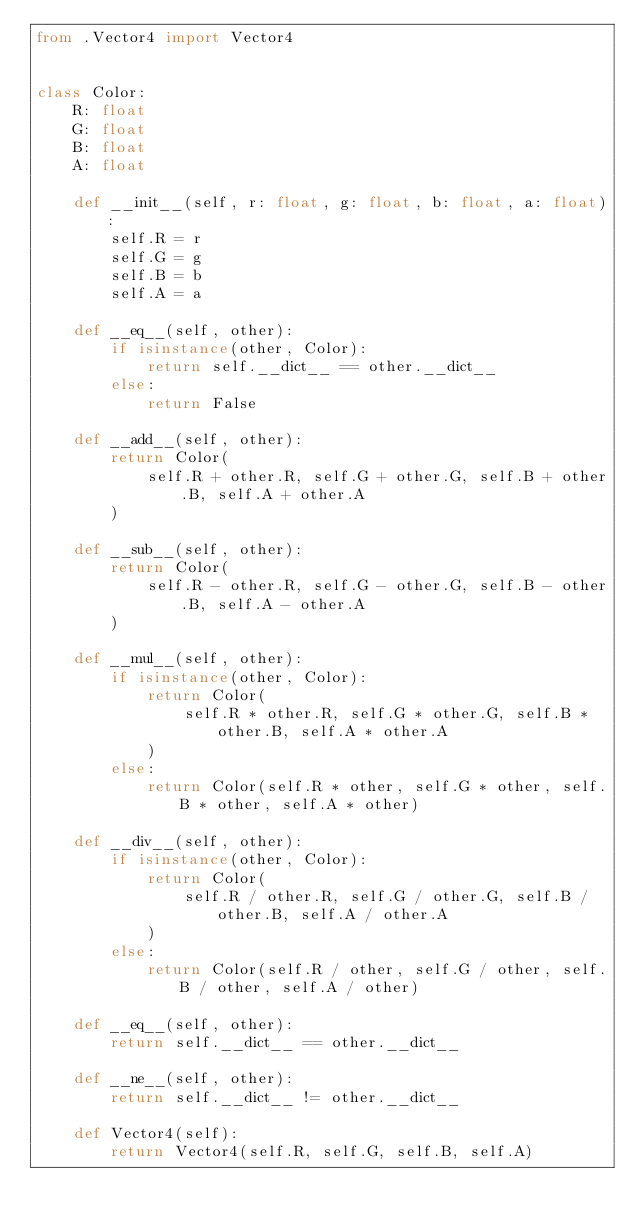Convert code to text. <code><loc_0><loc_0><loc_500><loc_500><_Python_>from .Vector4 import Vector4


class Color:
    R: float
    G: float
    B: float
    A: float

    def __init__(self, r: float, g: float, b: float, a: float):
        self.R = r
        self.G = g
        self.B = b
        self.A = a

    def __eq__(self, other):
        if isinstance(other, Color):
            return self.__dict__ == other.__dict__
        else:
            return False

    def __add__(self, other):
        return Color(
            self.R + other.R, self.G + other.G, self.B + other.B, self.A + other.A
        )

    def __sub__(self, other):
        return Color(
            self.R - other.R, self.G - other.G, self.B - other.B, self.A - other.A
        )

    def __mul__(self, other):
        if isinstance(other, Color):
            return Color(
                self.R * other.R, self.G * other.G, self.B * other.B, self.A * other.A
            )
        else:
            return Color(self.R * other, self.G * other, self.B * other, self.A * other)

    def __div__(self, other):
        if isinstance(other, Color):
            return Color(
                self.R / other.R, self.G / other.G, self.B / other.B, self.A / other.A
            )
        else:
            return Color(self.R / other, self.G / other, self.B / other, self.A / other)

    def __eq__(self, other):
        return self.__dict__ == other.__dict__

    def __ne__(self, other):
        return self.__dict__ != other.__dict__

    def Vector4(self):
        return Vector4(self.R, self.G, self.B, self.A)
</code> 